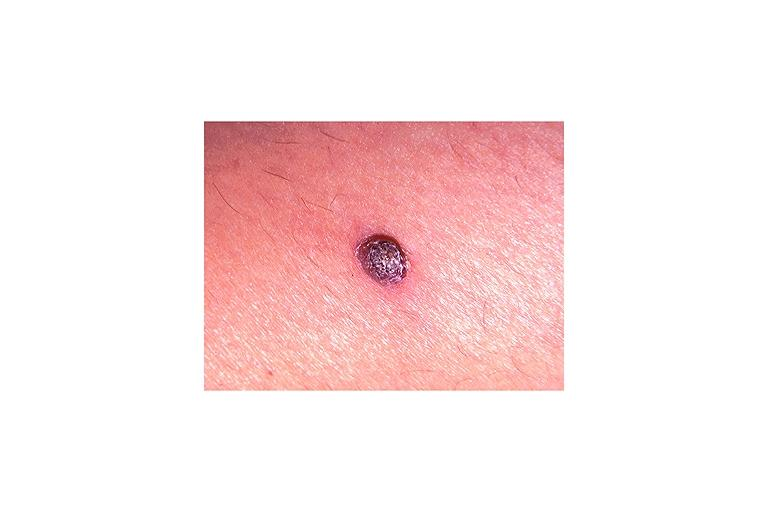does lymph node show verruca vulgaris?
Answer the question using a single word or phrase. No 